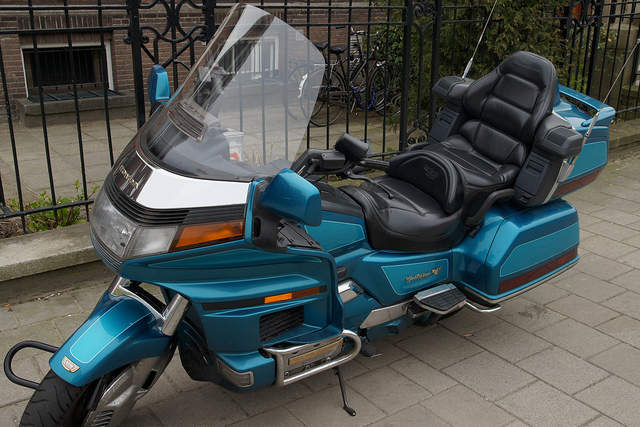What can you infer about the possible age or style of this motorcycle, given its design and aesthetics? This motorcycle has a classic touring design with a robust, luxury appearance indicative of models popular in the 1980s and 1990s. Its boxy shape, the extensive use of chrome, and the deep, metallic paint suggest it may be a vintage or retro-style bike. The comprehensive fairing and large, cushioned seats are consistent with motorcycles built for comfort over long rides, a signature of older touring models. 